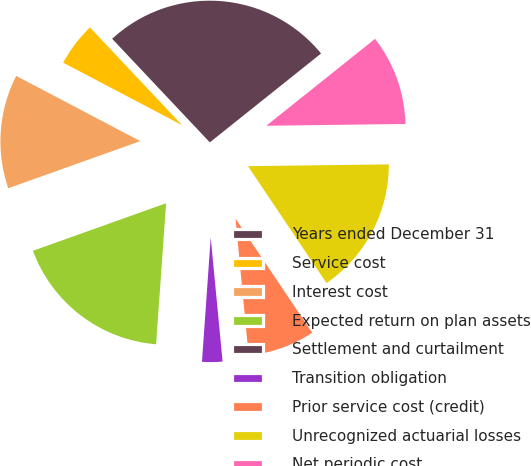Convert chart to OTSL. <chart><loc_0><loc_0><loc_500><loc_500><pie_chart><fcel>Years ended December 31<fcel>Service cost<fcel>Interest cost<fcel>Expected return on plan assets<fcel>Settlement and curtailment<fcel>Transition obligation<fcel>Prior service cost (credit)<fcel>Unrecognized actuarial losses<fcel>Net periodic cost<nl><fcel>26.31%<fcel>5.27%<fcel>13.16%<fcel>18.42%<fcel>0.01%<fcel>2.64%<fcel>7.9%<fcel>15.79%<fcel>10.53%<nl></chart> 